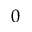<formula> <loc_0><loc_0><loc_500><loc_500>0</formula> 